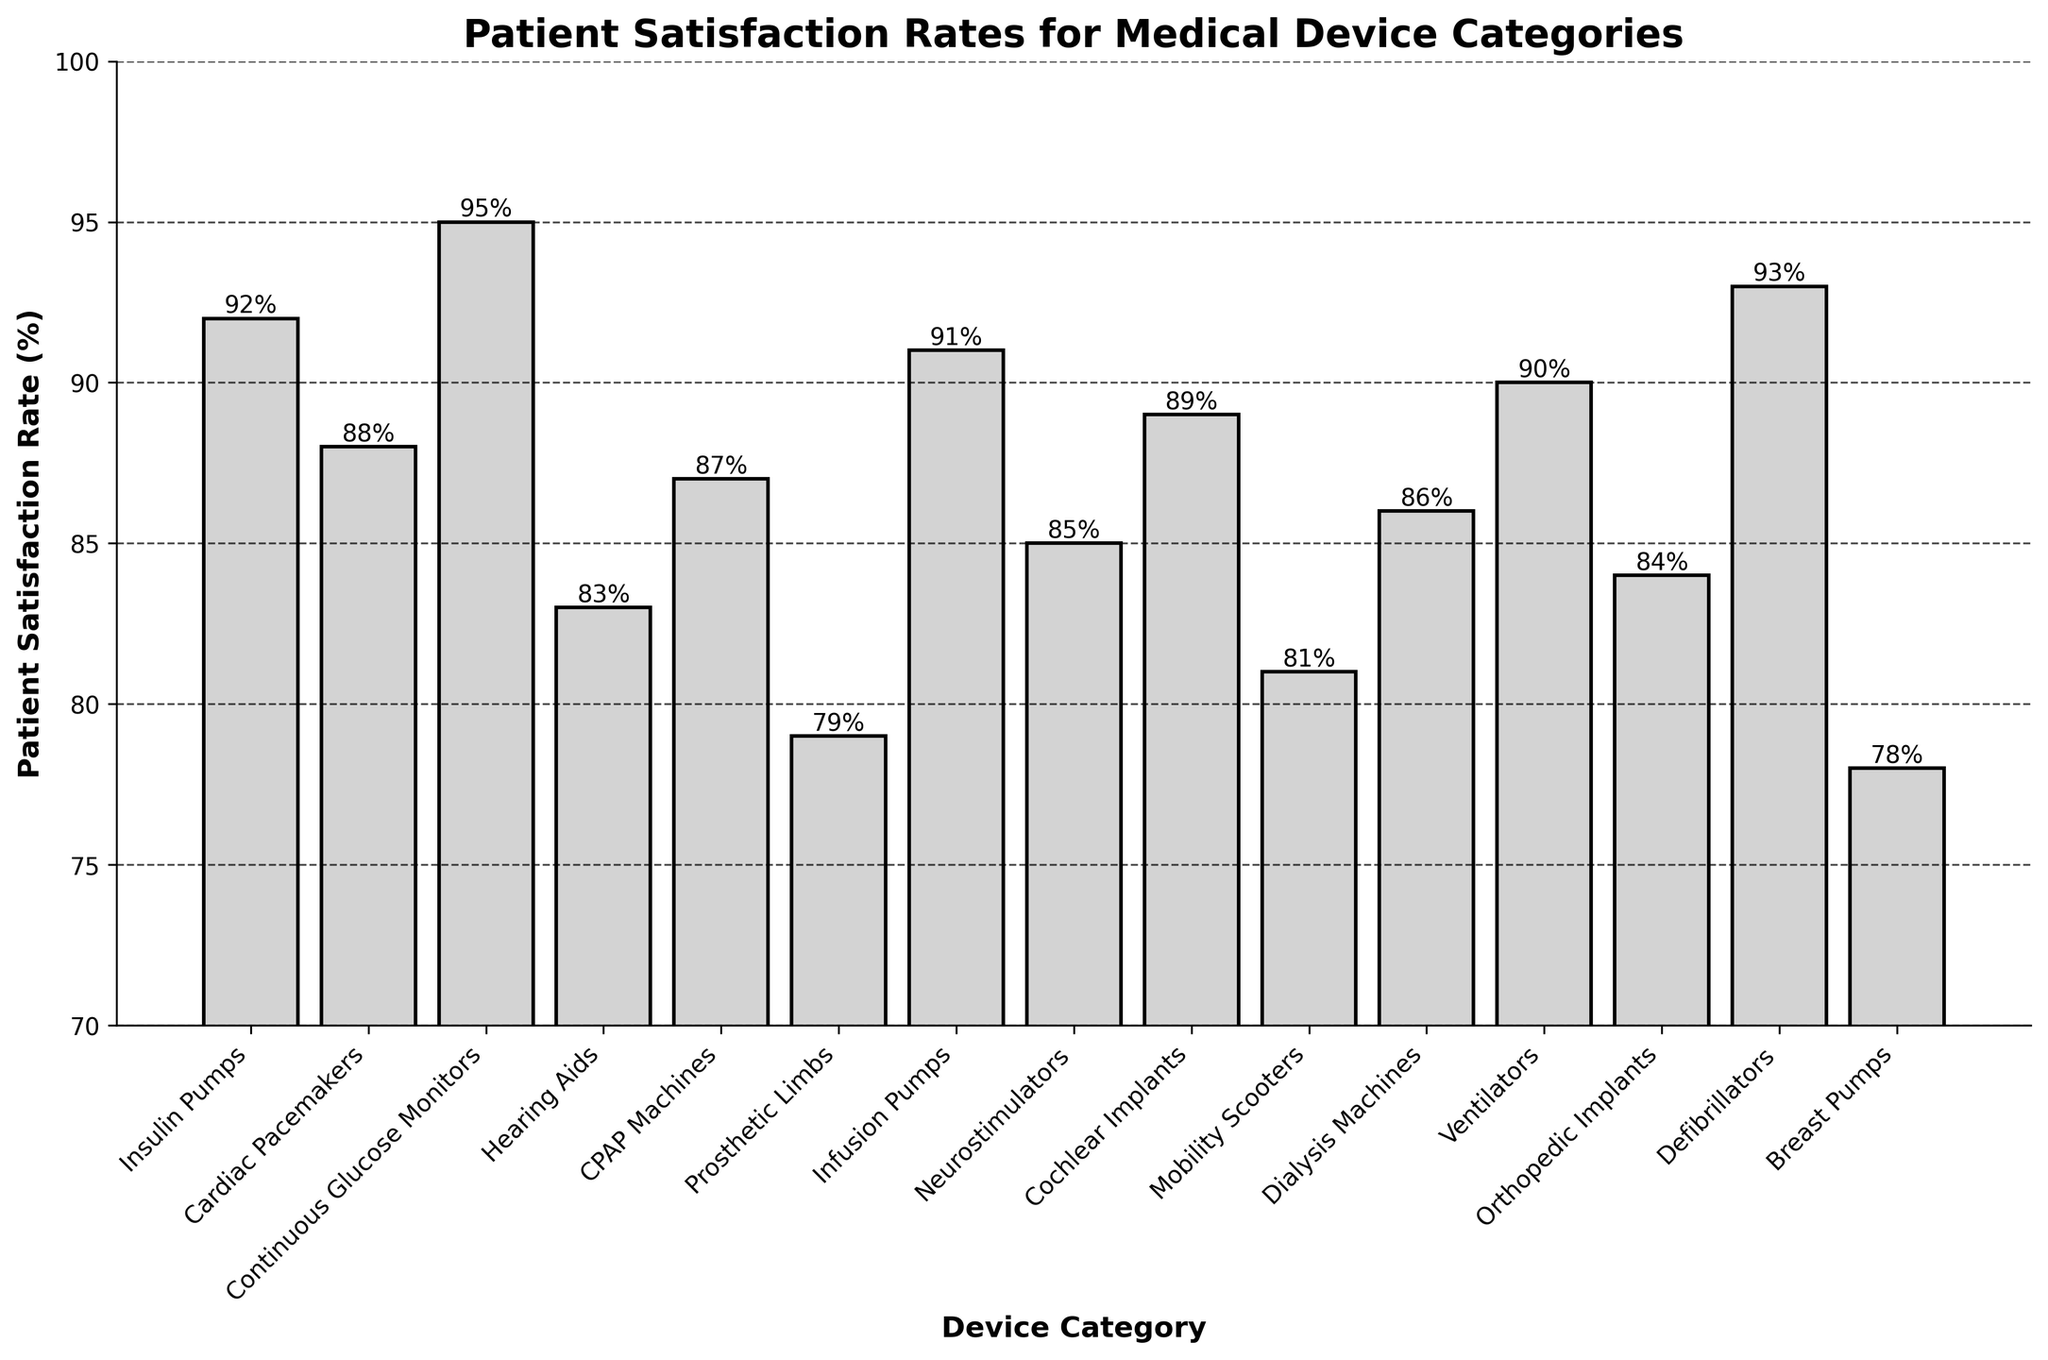Which medical device has the highest patient satisfaction rate? Look at the heights of all the bars and identify the tallest one, which represents the highest satisfaction rate.
Answer: Continuous Glucose Monitors What is the difference in patient satisfaction rates between Insulin Pumps and Prosthetic Limbs? Find the height of the bars for Insulin Pumps and Prosthetic Limbs, then subtract the smaller value from the larger one (92% - 79%).
Answer: 13% Among Cochlear Implants, Mobility Scooters, and Dialysis Machines, which has the lowest satisfaction rate? Compare the heights of the bars for these three categories and identify the shortest bar, which represents the lowest satisfaction rate.
Answer: Mobility Scooters Calculate the average patient satisfaction rate for CPAP Machines, Neurostimulators, and Ventilators. Add the heights of the bars for CPAP Machines (87%), Neurostimulators (85%), and Ventilators (90%), then divide by the number of categories (3). (87 + 85 + 90) / 3
Answer: 87.33% How many device categories have a patient satisfaction rate of 90% or above? Count the number of bars that reach or exceed the 90% mark on the y-axis.
Answer: 5 Which device category has a patient satisfaction rate closest to 85%? Identify the bar heights and find the one closest to 85% by comparing the absolute differences.
Answer: Neurostimulators Do Cardiac Pacemakers or Cochlear Implants have a higher patient satisfaction rate? Compare the heights of the bars for Cardiac Pacemakers and Cochlear Implants; the taller bar indicates a higher satisfaction rate.
Answer: Cochlear Implants What's the range of patient satisfaction rates for the categories shown in the bar chart? Find the difference between the highest satisfaction rate (Continuous Glucose Monitors at 95%) and the lowest rate (Breast Pumps at 78%).
Answer: 17% By how much does the patient satisfaction rate for Defibrillators exceed that for Infusion Pumps? Identify the bar heights for Defibrillators (93%) and Infusion Pumps (91%), then subtract the smaller value from the larger one.
Answer: 2% 